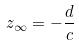<formula> <loc_0><loc_0><loc_500><loc_500>z _ { \infty } = - \frac { d } { c }</formula> 